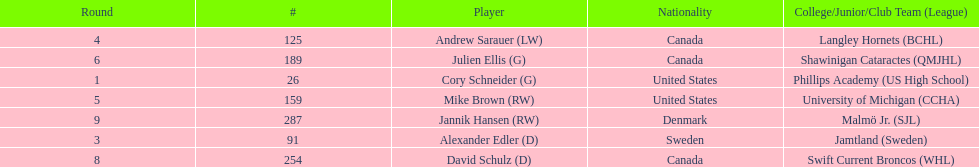How many goalie picks? 2. 